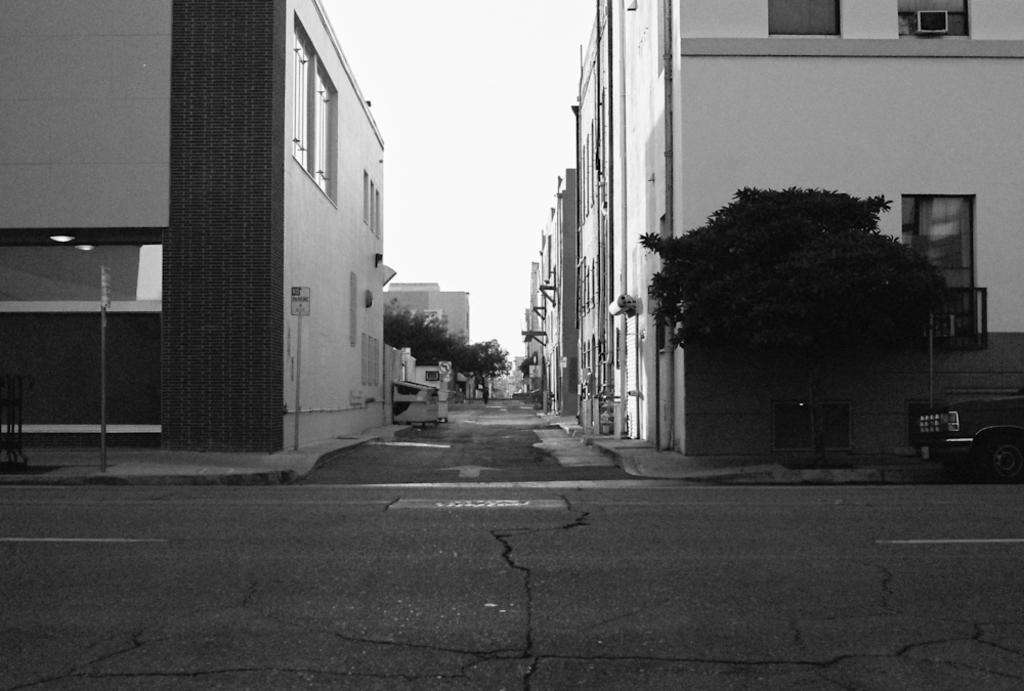What type of structures can be seen in the image? There are buildings in the image. What other natural elements are present in the image? There are trees in the image. What can be seen in the distance in the image? The sky is visible in the background of the image. What song is being sung by the trees in the image? There are no trees singing in the image; trees do not have the ability to sing. 